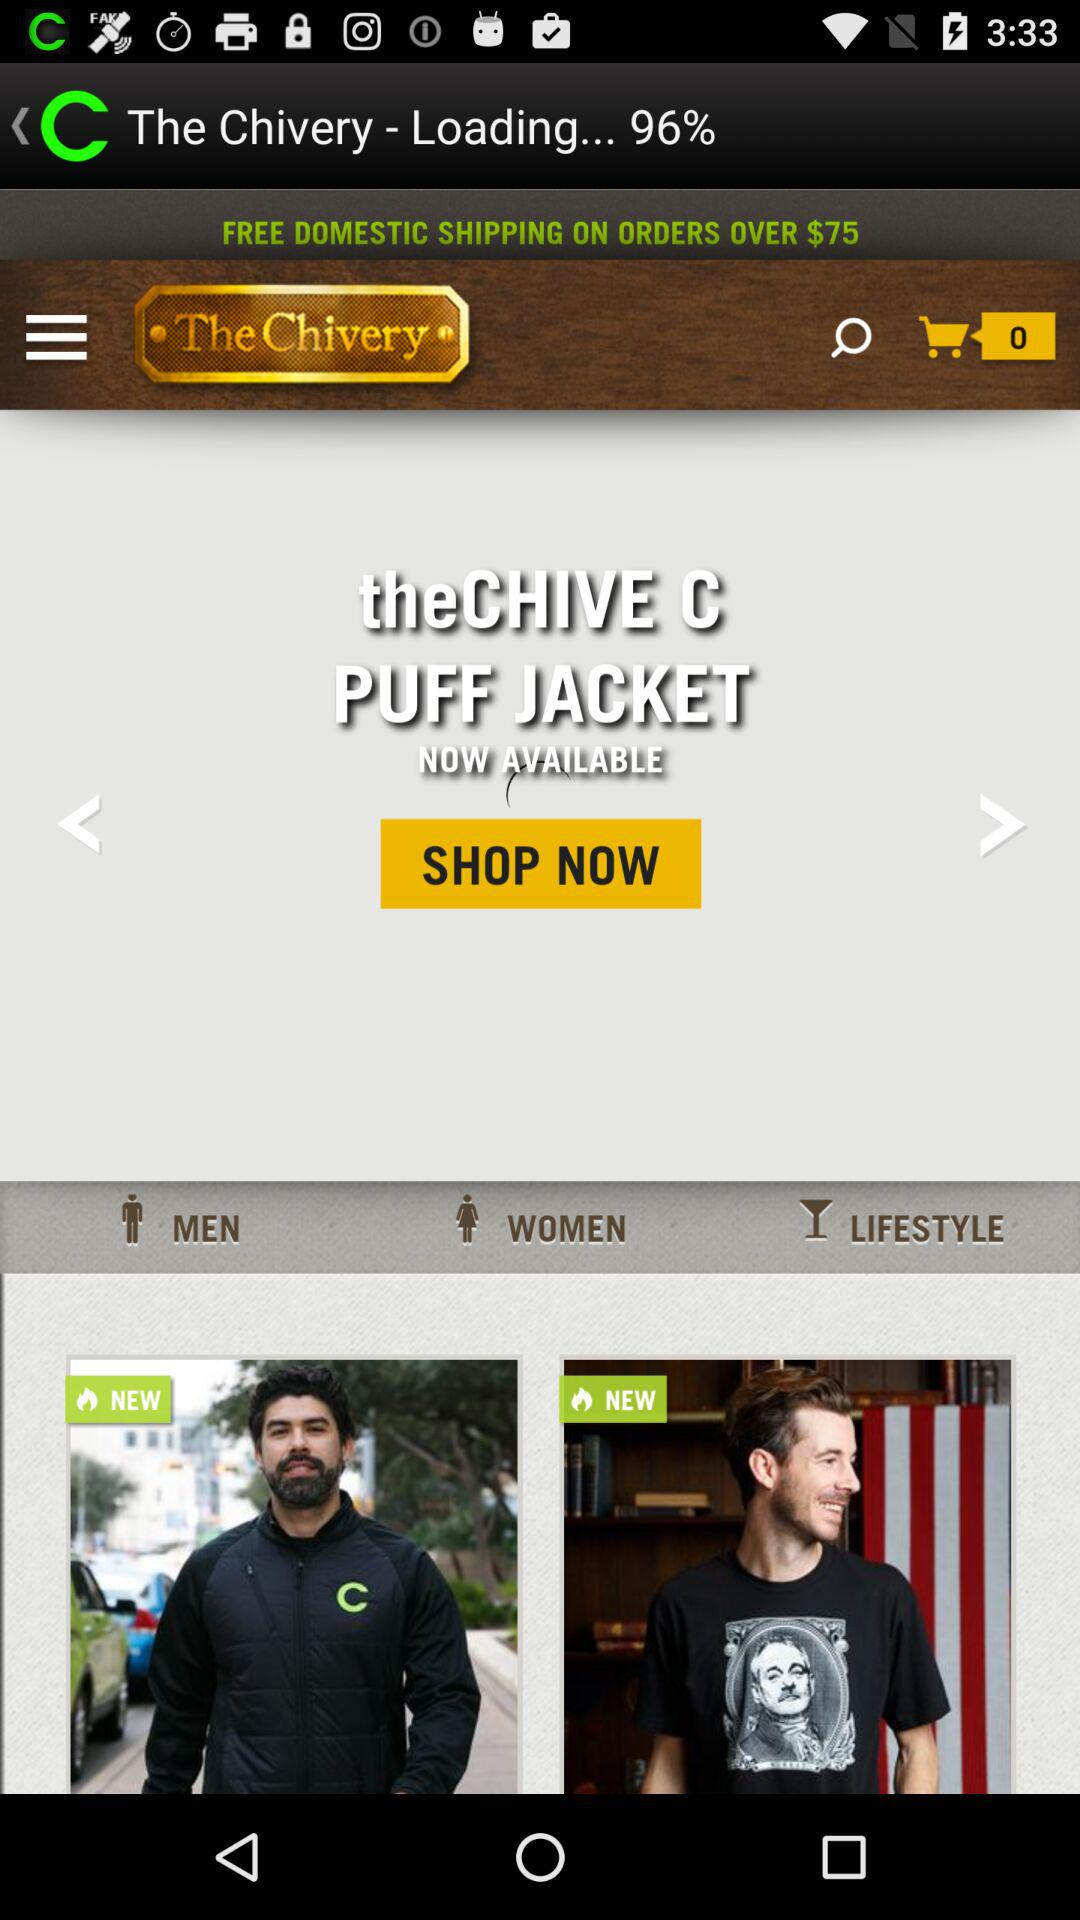Is there any item in the cart?
When the provided information is insufficient, respond with <no answer>. <no answer> 